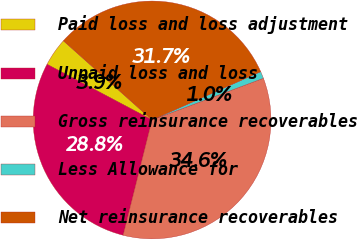<chart> <loc_0><loc_0><loc_500><loc_500><pie_chart><fcel>Paid loss and loss adjustment<fcel>Unpaid loss and loss<fcel>Gross reinsurance recoverables<fcel>Less Allowance for<fcel>Net reinsurance recoverables<nl><fcel>3.85%<fcel>28.84%<fcel>34.61%<fcel>0.96%<fcel>31.73%<nl></chart> 